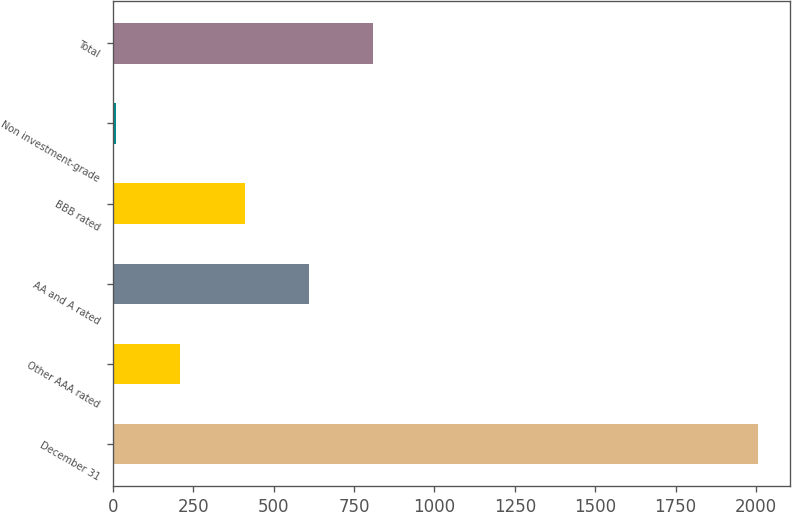<chart> <loc_0><loc_0><loc_500><loc_500><bar_chart><fcel>December 31<fcel>Other AAA rated<fcel>AA and A rated<fcel>BBB rated<fcel>Non investment-grade<fcel>Total<nl><fcel>2005<fcel>210.4<fcel>609.2<fcel>409.8<fcel>11<fcel>808.6<nl></chart> 